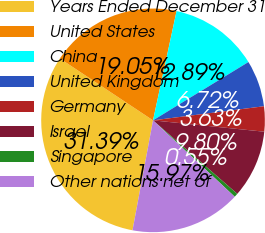<chart> <loc_0><loc_0><loc_500><loc_500><pie_chart><fcel>Years Ended December 31<fcel>United States<fcel>China<fcel>United Kingdom<fcel>Germany<fcel>Israel<fcel>Singapore<fcel>Other nations net of<nl><fcel>31.39%<fcel>19.05%<fcel>12.89%<fcel>6.72%<fcel>3.63%<fcel>9.8%<fcel>0.55%<fcel>15.97%<nl></chart> 